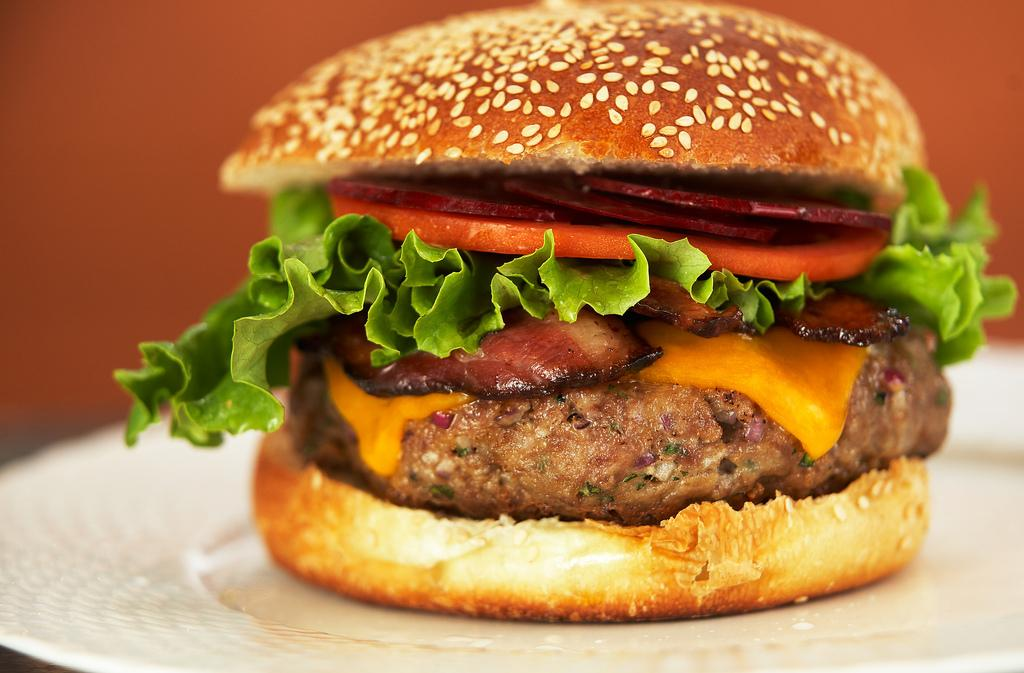What type of food is visible in the image? There is a burger in the image. Where is the burger located? The burger is on a plate. Can you describe the background of the image? The background of the image is blurry. What type of plant can be seen growing on the floor in the image? There is no plant visible on the floor in the image. 